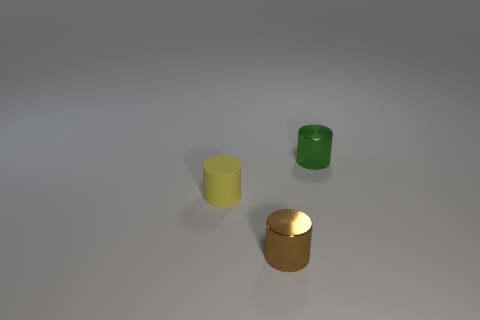Subtract all small brown cylinders. How many cylinders are left? 2 Add 1 green cylinders. How many objects exist? 4 Subtract 0 yellow blocks. How many objects are left? 3 Subtract all big yellow cubes. Subtract all small cylinders. How many objects are left? 0 Add 1 small green objects. How many small green objects are left? 2 Add 1 small brown metal cylinders. How many small brown metal cylinders exist? 2 